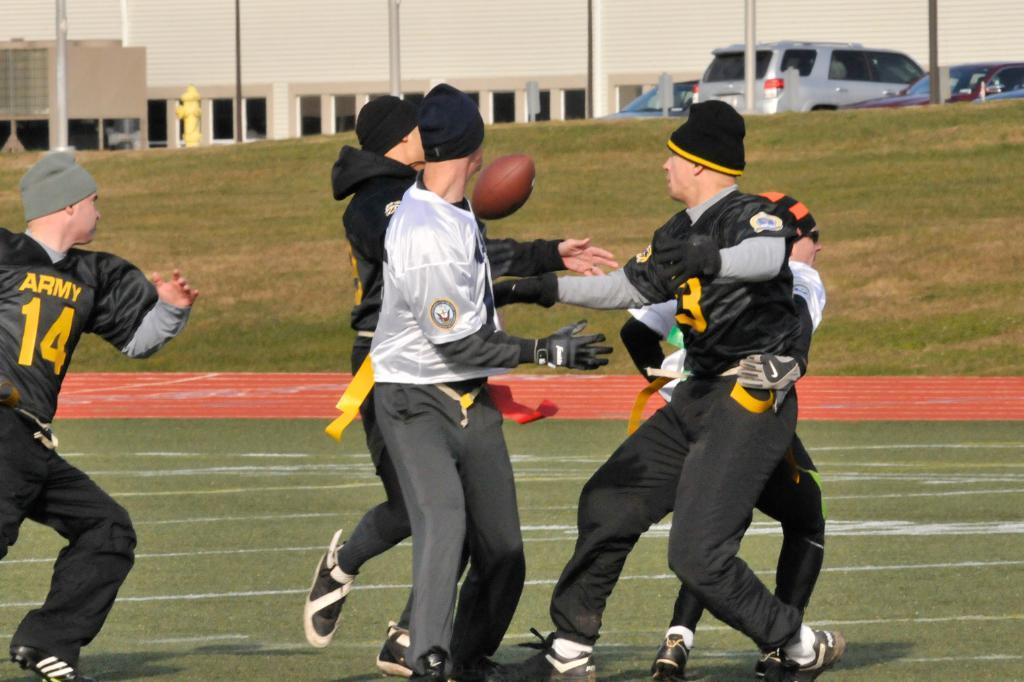What sport are the people playing in the image? The people are playing rugby in the image. What type of surface are they playing on? There is a ground in the image, which is likely the playing surface. What can be seen in the background of the image? Buildings and poles are visible in the image. Are there any vehicles present in the image? Yes, there are vehicles in the image. What type of vegetation is present in the image? There is grass in the image. What other object can be seen in the image? There is a fire hydrant in the image. How many sisters are playing rugby in the image? There is no mention of sisters in the image, and the number of players is not specified. 